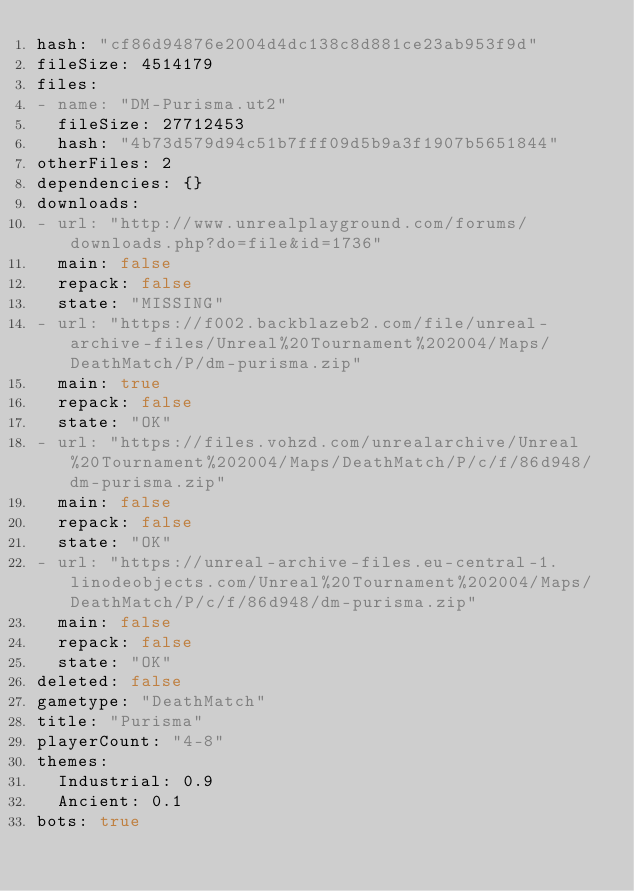Convert code to text. <code><loc_0><loc_0><loc_500><loc_500><_YAML_>hash: "cf86d94876e2004d4dc138c8d881ce23ab953f9d"
fileSize: 4514179
files:
- name: "DM-Purisma.ut2"
  fileSize: 27712453
  hash: "4b73d579d94c51b7fff09d5b9a3f1907b5651844"
otherFiles: 2
dependencies: {}
downloads:
- url: "http://www.unrealplayground.com/forums/downloads.php?do=file&id=1736"
  main: false
  repack: false
  state: "MISSING"
- url: "https://f002.backblazeb2.com/file/unreal-archive-files/Unreal%20Tournament%202004/Maps/DeathMatch/P/dm-purisma.zip"
  main: true
  repack: false
  state: "OK"
- url: "https://files.vohzd.com/unrealarchive/Unreal%20Tournament%202004/Maps/DeathMatch/P/c/f/86d948/dm-purisma.zip"
  main: false
  repack: false
  state: "OK"
- url: "https://unreal-archive-files.eu-central-1.linodeobjects.com/Unreal%20Tournament%202004/Maps/DeathMatch/P/c/f/86d948/dm-purisma.zip"
  main: false
  repack: false
  state: "OK"
deleted: false
gametype: "DeathMatch"
title: "Purisma"
playerCount: "4-8"
themes:
  Industrial: 0.9
  Ancient: 0.1
bots: true
</code> 